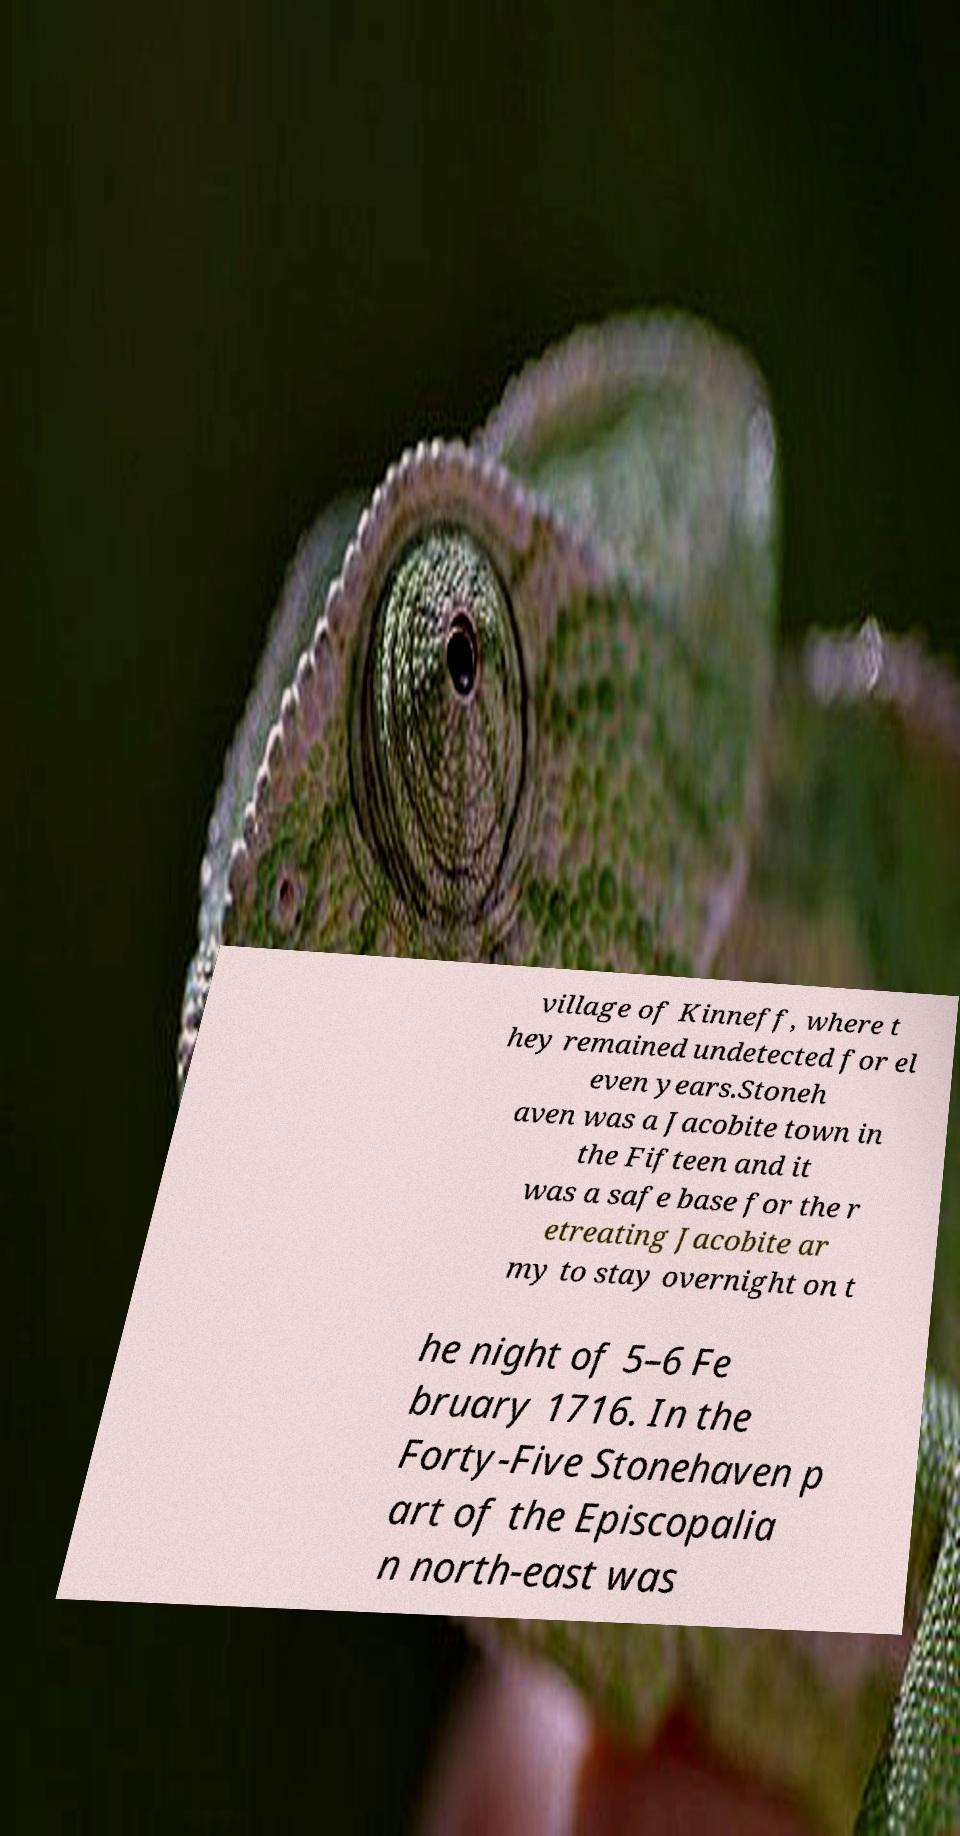Could you assist in decoding the text presented in this image and type it out clearly? village of Kinneff, where t hey remained undetected for el even years.Stoneh aven was a Jacobite town in the Fifteen and it was a safe base for the r etreating Jacobite ar my to stay overnight on t he night of 5–6 Fe bruary 1716. In the Forty-Five Stonehaven p art of the Episcopalia n north-east was 